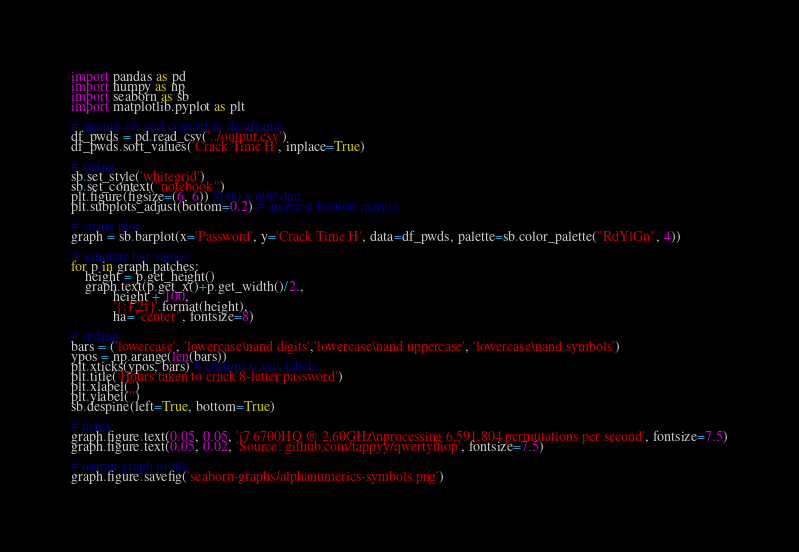Convert code to text. <code><loc_0><loc_0><loc_500><loc_500><_Python_>import pandas as pd
import numpy as np
import seaborn as sb
import matplotlib.pyplot as plt

# import csv and convert to dataframe
df_pwds = pd.read_csv('../output.csv')
df_pwds.sort_values('Crack Time H', inplace=True)

# sizing
sb.set_style('whitegrid')
sb.set_context("notebook")
plt.figure(figsize=(6, 6)) #600 x 600 dim
plt.subplots_adjust(bottom=0.2) # increase bottom margin

# create plot
graph = sb.barplot(x='Password', y='Crack Time H', data=df_pwds, palette=sb.color_palette("RdYlGn", 4))

# annotate bar values
for p in graph.patches:
    height = p.get_height()
    graph.text(p.get_x()+p.get_width()/2.,
            height + 100,
            '{:1.2f}'.format(height),
            ha="center", fontsize=8)

# styling
bars = ('lowercase', 'lowercase\nand digits','lowercase\nand uppercase', 'lowercase\nand symbols')
ypos = np.arange(len(bars))
plt.xticks(ypos, bars) # custom x-axis labels
plt.title('Hours taken to crack 8-letter password')
plt.xlabel('')
plt.ylabel('')
sb.despine(left=True, bottom=True)

# notes
graph.figure.text(0.05, 0.05, 'i7 6700HQ @ 2.60GHz\nprocessing 6,591,804 permutations per second', fontsize=7.5)
graph.figure.text(0.05, 0.02, 'Source: github.com/tappyy/qwertyuiop', fontsize=7.5)

# output graph to file
graph.figure.savefig('seaborn-graphs/alphanumerics-symbols.png')
</code> 